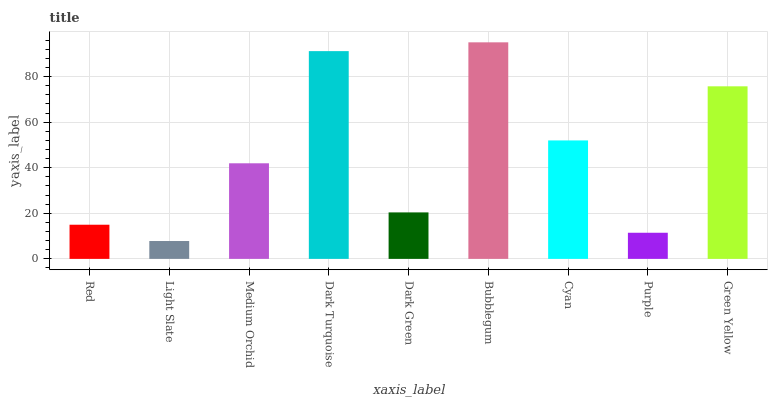Is Medium Orchid the minimum?
Answer yes or no. No. Is Medium Orchid the maximum?
Answer yes or no. No. Is Medium Orchid greater than Light Slate?
Answer yes or no. Yes. Is Light Slate less than Medium Orchid?
Answer yes or no. Yes. Is Light Slate greater than Medium Orchid?
Answer yes or no. No. Is Medium Orchid less than Light Slate?
Answer yes or no. No. Is Medium Orchid the high median?
Answer yes or no. Yes. Is Medium Orchid the low median?
Answer yes or no. Yes. Is Light Slate the high median?
Answer yes or no. No. Is Red the low median?
Answer yes or no. No. 